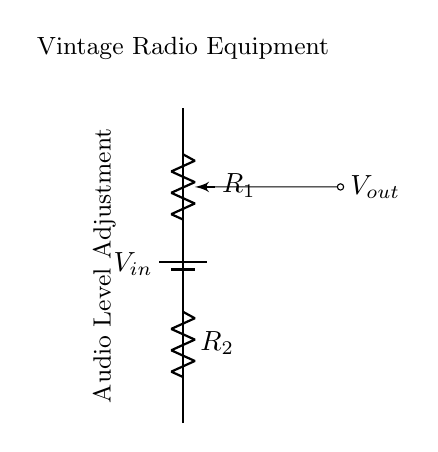What is the input voltage represented in the circuit? In the circuit, the input voltage is denoted as V_in attached to the battery symbol, indicating the source of power for the circuit.
Answer: V_in What components are present in this voltage divider? The voltage divider consists of two resistors: R1 as a potentiometer and R2 as a fixed resistor. These components are essential for dividing the voltage and adjusting audio levels.
Answer: R1, R2 What is the purpose of the wiper in the potentiometer? The wiper of the potentiometer allows for variable resistance which enables the adjustment of voltage output to tailor audio levels as desired in vintage radio equipment.
Answer: Adjust audio levels What is the function of the output in this circuit? The output in this circuit, labeled as V_out, represents the voltage that can be taken from the voltage divider to adjust the audio signal level in the vintage radio.
Answer: V_out How does changing R1 affect the output voltage? Changing R1 alters the resistance ratio between R1 and R2, which in turn adjusts the division of the input voltage, impacting the V_out based on the voltage divider rule.
Answer: Changes V_out What type of circuit is illustrated in this diagram? The diagram illustrates a voltage divider circuit specifically designed for adjusting audio levels in equipment like vintage radios, demonstrating the division of voltage using resistors.
Answer: Voltage divider What does the notation “Audio Level Adjustment” signify in the circuit? The notation “Audio Level Adjustment” indicates the purpose of the potentiometer in this circuit, which is to modify or control the audio levels output to the speaker or audio component.
Answer: Modify audio levels 